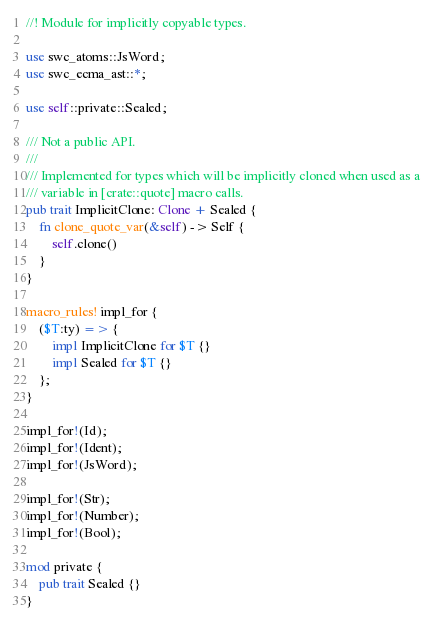Convert code to text. <code><loc_0><loc_0><loc_500><loc_500><_Rust_>//! Module for implicitly copyable types.

use swc_atoms::JsWord;
use swc_ecma_ast::*;

use self::private::Sealed;

/// Not a public API.
///
/// Implemented for types which will be implicitly cloned when used as a
/// variable in [crate::quote] macro calls.
pub trait ImplicitClone: Clone + Sealed {
    fn clone_quote_var(&self) -> Self {
        self.clone()
    }
}

macro_rules! impl_for {
    ($T:ty) => {
        impl ImplicitClone for $T {}
        impl Sealed for $T {}
    };
}

impl_for!(Id);
impl_for!(Ident);
impl_for!(JsWord);

impl_for!(Str);
impl_for!(Number);
impl_for!(Bool);

mod private {
    pub trait Sealed {}
}
</code> 